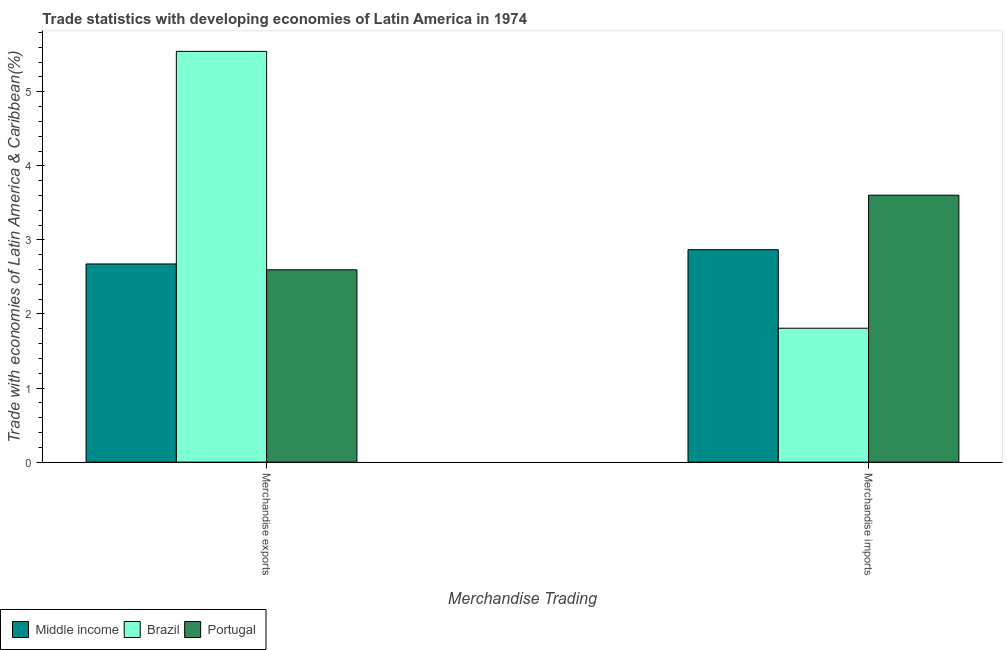How many different coloured bars are there?
Keep it short and to the point. 3. What is the merchandise exports in Portugal?
Offer a very short reply. 2.6. Across all countries, what is the maximum merchandise imports?
Keep it short and to the point. 3.6. Across all countries, what is the minimum merchandise imports?
Your response must be concise. 1.81. What is the total merchandise exports in the graph?
Your answer should be very brief. 10.82. What is the difference between the merchandise imports in Brazil and that in Portugal?
Provide a succinct answer. -1.8. What is the difference between the merchandise imports in Portugal and the merchandise exports in Middle income?
Provide a succinct answer. 0.93. What is the average merchandise imports per country?
Make the answer very short. 2.76. What is the difference between the merchandise imports and merchandise exports in Middle income?
Your answer should be compact. 0.19. In how many countries, is the merchandise exports greater than 3.4 %?
Your answer should be very brief. 1. What is the ratio of the merchandise imports in Brazil to that in Portugal?
Keep it short and to the point. 0.5. Is the merchandise imports in Middle income less than that in Brazil?
Keep it short and to the point. No. What does the 3rd bar from the left in Merchandise imports represents?
Ensure brevity in your answer.  Portugal. What does the 1st bar from the right in Merchandise imports represents?
Provide a succinct answer. Portugal. Are all the bars in the graph horizontal?
Your answer should be very brief. No. How many countries are there in the graph?
Your response must be concise. 3. What is the difference between two consecutive major ticks on the Y-axis?
Offer a very short reply. 1. What is the title of the graph?
Give a very brief answer. Trade statistics with developing economies of Latin America in 1974. Does "Djibouti" appear as one of the legend labels in the graph?
Ensure brevity in your answer.  No. What is the label or title of the X-axis?
Ensure brevity in your answer.  Merchandise Trading. What is the label or title of the Y-axis?
Offer a terse response. Trade with economies of Latin America & Caribbean(%). What is the Trade with economies of Latin America & Caribbean(%) of Middle income in Merchandise exports?
Ensure brevity in your answer.  2.68. What is the Trade with economies of Latin America & Caribbean(%) of Brazil in Merchandise exports?
Keep it short and to the point. 5.55. What is the Trade with economies of Latin America & Caribbean(%) in Portugal in Merchandise exports?
Provide a succinct answer. 2.6. What is the Trade with economies of Latin America & Caribbean(%) in Middle income in Merchandise imports?
Your response must be concise. 2.87. What is the Trade with economies of Latin America & Caribbean(%) in Brazil in Merchandise imports?
Keep it short and to the point. 1.81. What is the Trade with economies of Latin America & Caribbean(%) of Portugal in Merchandise imports?
Provide a short and direct response. 3.6. Across all Merchandise Trading, what is the maximum Trade with economies of Latin America & Caribbean(%) of Middle income?
Your answer should be very brief. 2.87. Across all Merchandise Trading, what is the maximum Trade with economies of Latin America & Caribbean(%) of Brazil?
Keep it short and to the point. 5.55. Across all Merchandise Trading, what is the maximum Trade with economies of Latin America & Caribbean(%) in Portugal?
Offer a very short reply. 3.6. Across all Merchandise Trading, what is the minimum Trade with economies of Latin America & Caribbean(%) in Middle income?
Provide a short and direct response. 2.68. Across all Merchandise Trading, what is the minimum Trade with economies of Latin America & Caribbean(%) in Brazil?
Ensure brevity in your answer.  1.81. Across all Merchandise Trading, what is the minimum Trade with economies of Latin America & Caribbean(%) in Portugal?
Ensure brevity in your answer.  2.6. What is the total Trade with economies of Latin America & Caribbean(%) in Middle income in the graph?
Offer a terse response. 5.54. What is the total Trade with economies of Latin America & Caribbean(%) in Brazil in the graph?
Offer a very short reply. 7.35. What is the total Trade with economies of Latin America & Caribbean(%) in Portugal in the graph?
Offer a terse response. 6.2. What is the difference between the Trade with economies of Latin America & Caribbean(%) in Middle income in Merchandise exports and that in Merchandise imports?
Offer a terse response. -0.19. What is the difference between the Trade with economies of Latin America & Caribbean(%) in Brazil in Merchandise exports and that in Merchandise imports?
Provide a short and direct response. 3.74. What is the difference between the Trade with economies of Latin America & Caribbean(%) in Portugal in Merchandise exports and that in Merchandise imports?
Keep it short and to the point. -1.01. What is the difference between the Trade with economies of Latin America & Caribbean(%) in Middle income in Merchandise exports and the Trade with economies of Latin America & Caribbean(%) in Brazil in Merchandise imports?
Your answer should be very brief. 0.87. What is the difference between the Trade with economies of Latin America & Caribbean(%) in Middle income in Merchandise exports and the Trade with economies of Latin America & Caribbean(%) in Portugal in Merchandise imports?
Your answer should be very brief. -0.93. What is the difference between the Trade with economies of Latin America & Caribbean(%) in Brazil in Merchandise exports and the Trade with economies of Latin America & Caribbean(%) in Portugal in Merchandise imports?
Your answer should be compact. 1.94. What is the average Trade with economies of Latin America & Caribbean(%) of Middle income per Merchandise Trading?
Ensure brevity in your answer.  2.77. What is the average Trade with economies of Latin America & Caribbean(%) in Brazil per Merchandise Trading?
Your answer should be very brief. 3.68. What is the average Trade with economies of Latin America & Caribbean(%) in Portugal per Merchandise Trading?
Make the answer very short. 3.1. What is the difference between the Trade with economies of Latin America & Caribbean(%) in Middle income and Trade with economies of Latin America & Caribbean(%) in Brazil in Merchandise exports?
Your response must be concise. -2.87. What is the difference between the Trade with economies of Latin America & Caribbean(%) in Middle income and Trade with economies of Latin America & Caribbean(%) in Portugal in Merchandise exports?
Keep it short and to the point. 0.08. What is the difference between the Trade with economies of Latin America & Caribbean(%) in Brazil and Trade with economies of Latin America & Caribbean(%) in Portugal in Merchandise exports?
Give a very brief answer. 2.95. What is the difference between the Trade with economies of Latin America & Caribbean(%) in Middle income and Trade with economies of Latin America & Caribbean(%) in Brazil in Merchandise imports?
Give a very brief answer. 1.06. What is the difference between the Trade with economies of Latin America & Caribbean(%) of Middle income and Trade with economies of Latin America & Caribbean(%) of Portugal in Merchandise imports?
Provide a short and direct response. -0.74. What is the difference between the Trade with economies of Latin America & Caribbean(%) in Brazil and Trade with economies of Latin America & Caribbean(%) in Portugal in Merchandise imports?
Offer a very short reply. -1.8. What is the ratio of the Trade with economies of Latin America & Caribbean(%) of Middle income in Merchandise exports to that in Merchandise imports?
Ensure brevity in your answer.  0.93. What is the ratio of the Trade with economies of Latin America & Caribbean(%) of Brazil in Merchandise exports to that in Merchandise imports?
Make the answer very short. 3.07. What is the ratio of the Trade with economies of Latin America & Caribbean(%) in Portugal in Merchandise exports to that in Merchandise imports?
Give a very brief answer. 0.72. What is the difference between the highest and the second highest Trade with economies of Latin America & Caribbean(%) in Middle income?
Offer a terse response. 0.19. What is the difference between the highest and the second highest Trade with economies of Latin America & Caribbean(%) of Brazil?
Offer a very short reply. 3.74. What is the difference between the highest and the second highest Trade with economies of Latin America & Caribbean(%) in Portugal?
Ensure brevity in your answer.  1.01. What is the difference between the highest and the lowest Trade with economies of Latin America & Caribbean(%) in Middle income?
Ensure brevity in your answer.  0.19. What is the difference between the highest and the lowest Trade with economies of Latin America & Caribbean(%) of Brazil?
Make the answer very short. 3.74. What is the difference between the highest and the lowest Trade with economies of Latin America & Caribbean(%) in Portugal?
Give a very brief answer. 1.01. 